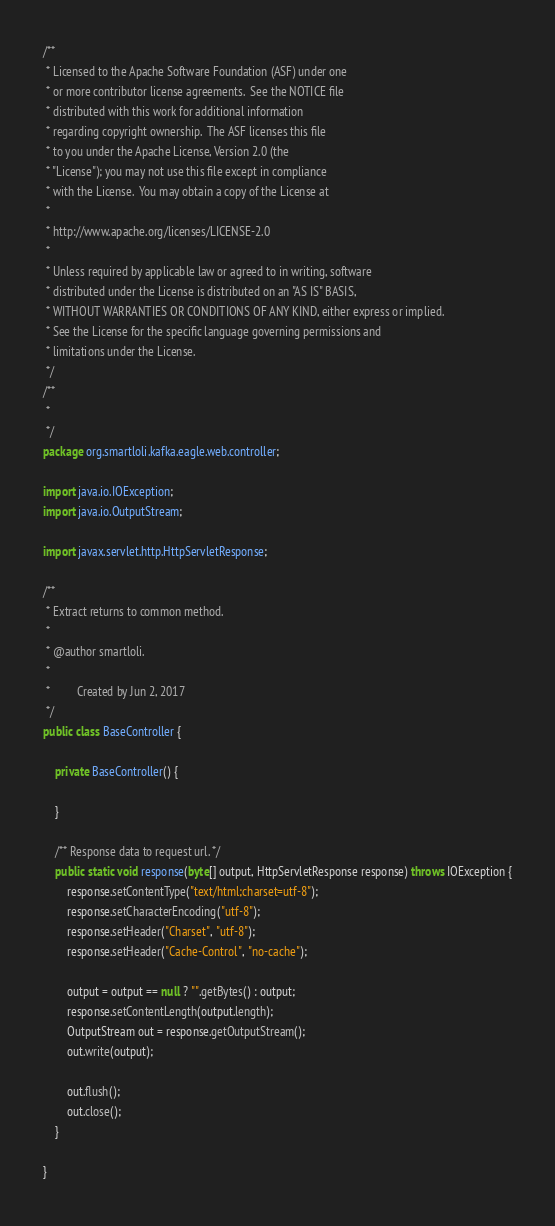<code> <loc_0><loc_0><loc_500><loc_500><_Java_>/**
 * Licensed to the Apache Software Foundation (ASF) under one
 * or more contributor license agreements.  See the NOTICE file
 * distributed with this work for additional information
 * regarding copyright ownership.  The ASF licenses this file
 * to you under the Apache License, Version 2.0 (the
 * "License"); you may not use this file except in compliance
 * with the License.  You may obtain a copy of the License at
 *
 * http://www.apache.org/licenses/LICENSE-2.0
 *
 * Unless required by applicable law or agreed to in writing, software
 * distributed under the License is distributed on an "AS IS" BASIS,
 * WITHOUT WARRANTIES OR CONDITIONS OF ANY KIND, either express or implied.
 * See the License for the specific language governing permissions and
 * limitations under the License.
 */
/**
 * 
 */
package org.smartloli.kafka.eagle.web.controller;

import java.io.IOException;
import java.io.OutputStream;

import javax.servlet.http.HttpServletResponse;

/**
 * Extract returns to common method.
 * 
 * @author smartloli.
 *
 *         Created by Jun 2, 2017
 */
public class BaseController {
	
	private BaseController() {
		
	}

	/** Response data to request url. */
	public static void response(byte[] output, HttpServletResponse response) throws IOException {
		response.setContentType("text/html;charset=utf-8");
		response.setCharacterEncoding("utf-8");
		response.setHeader("Charset", "utf-8");
		response.setHeader("Cache-Control", "no-cache");

		output = output == null ? "".getBytes() : output;
		response.setContentLength(output.length);
		OutputStream out = response.getOutputStream();
		out.write(output);

		out.flush();
		out.close();
	}

}
</code> 